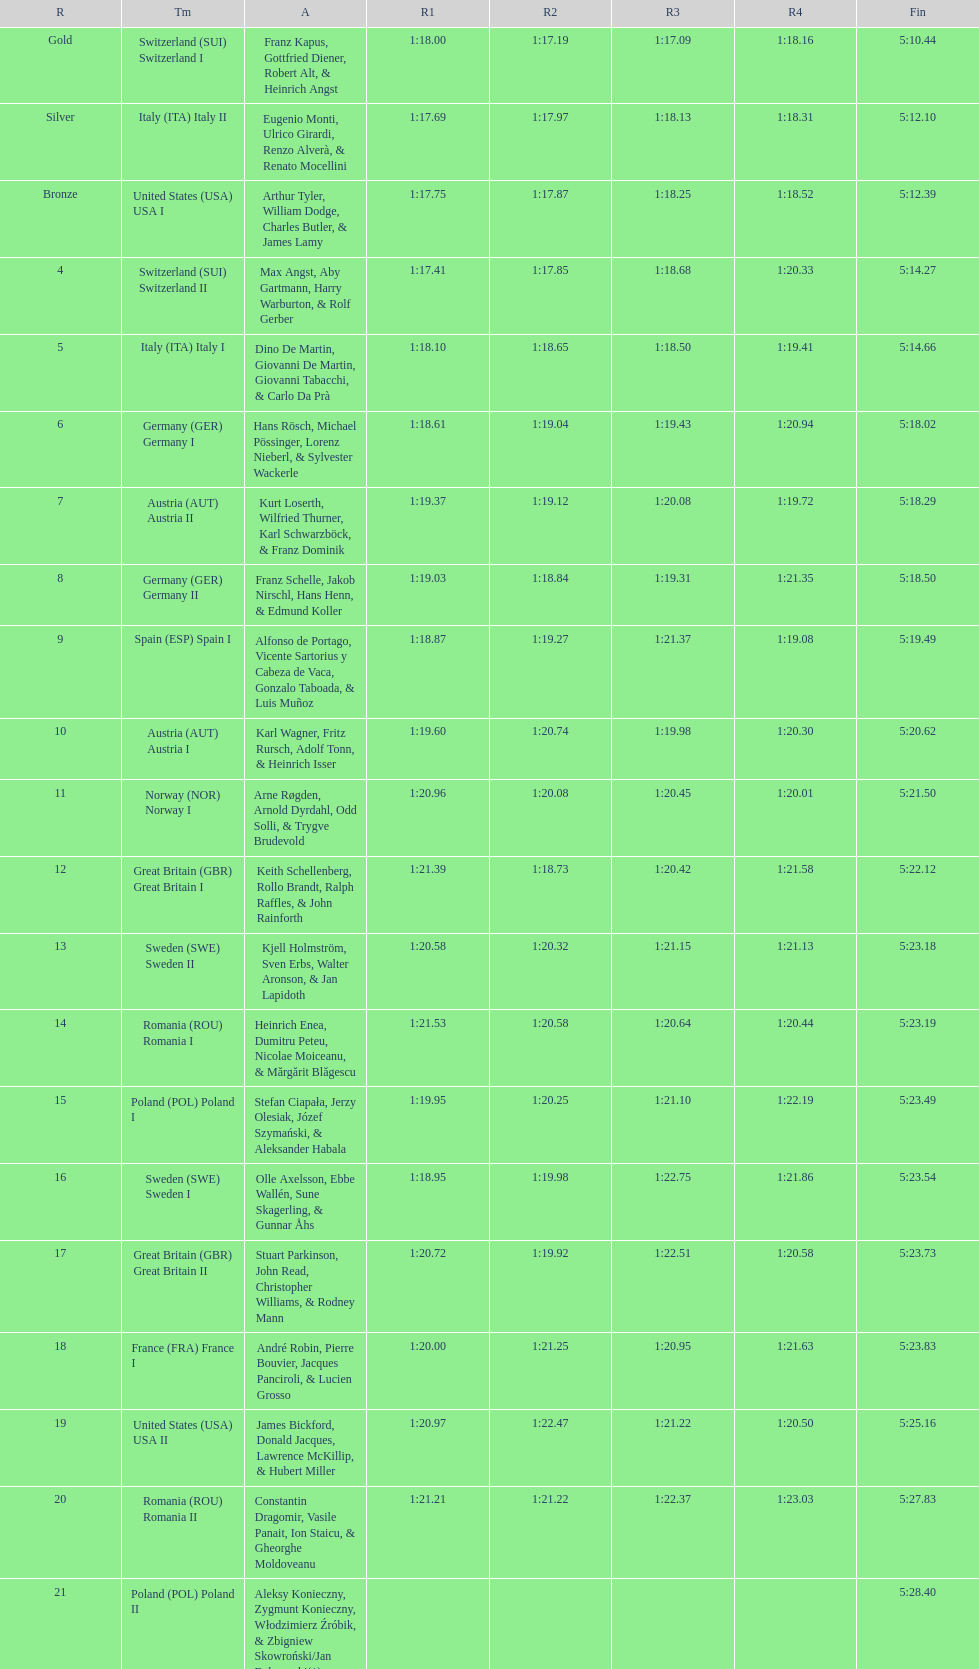Who placed the highest, italy or germany? Italy. 